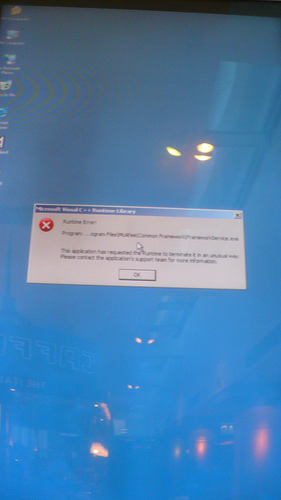<image>
Is there a monitor under the error message? No. The monitor is not positioned under the error message. The vertical relationship between these objects is different. 